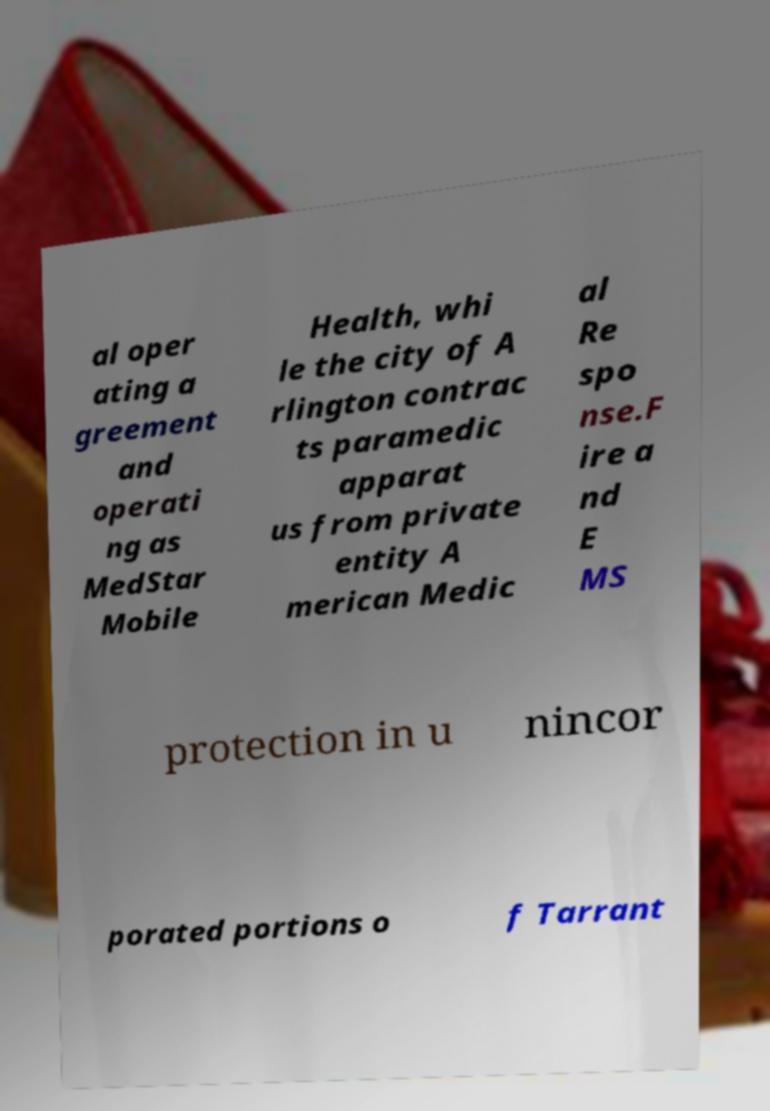What messages or text are displayed in this image? I need them in a readable, typed format. al oper ating a greement and operati ng as MedStar Mobile Health, whi le the city of A rlington contrac ts paramedic apparat us from private entity A merican Medic al Re spo nse.F ire a nd E MS protection in u nincor porated portions o f Tarrant 